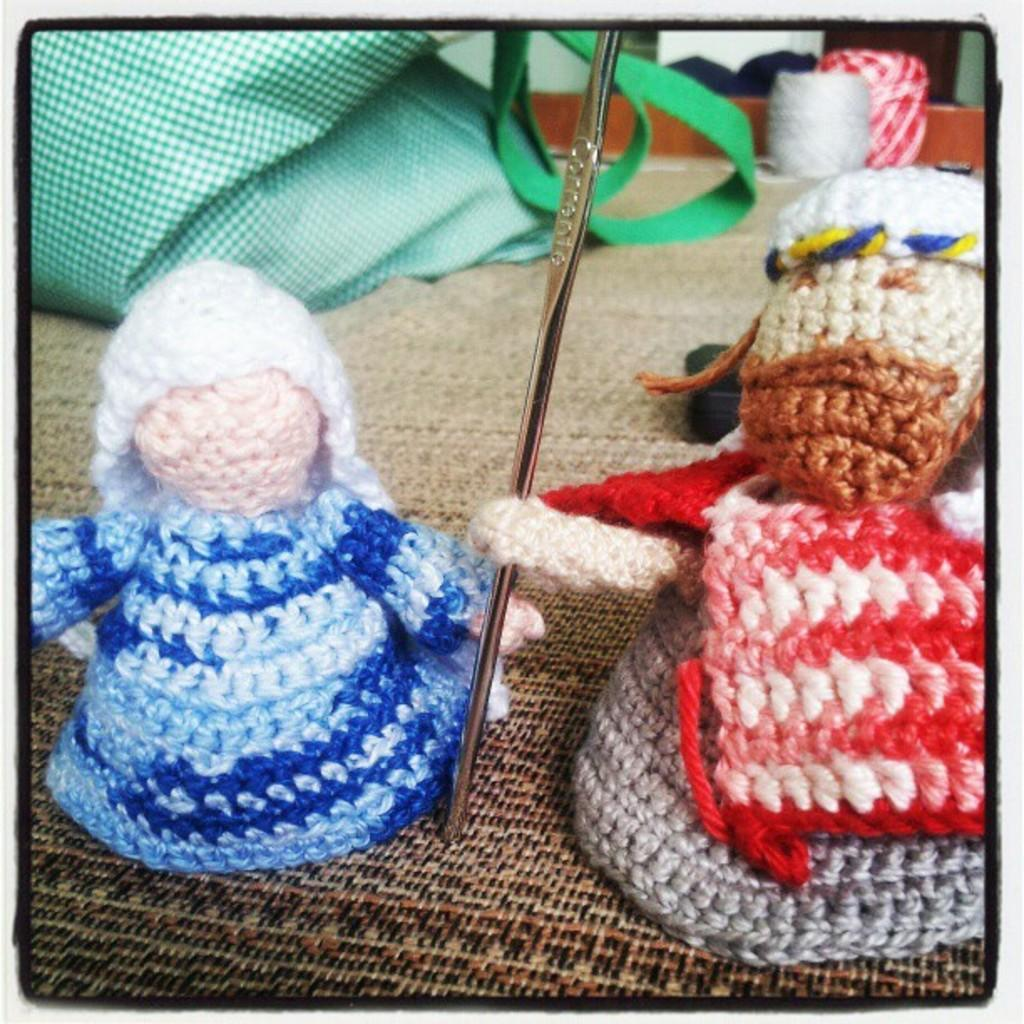What type of dolls are in the image? There are two woolen dolls in the image. What can be seen in the middle of the image? There is a stainless pin in the middle of the image. How many trees can be seen in the image? There are no trees present in the image. What word is written on the pan in the image? There is no pan or any written word in the image. 